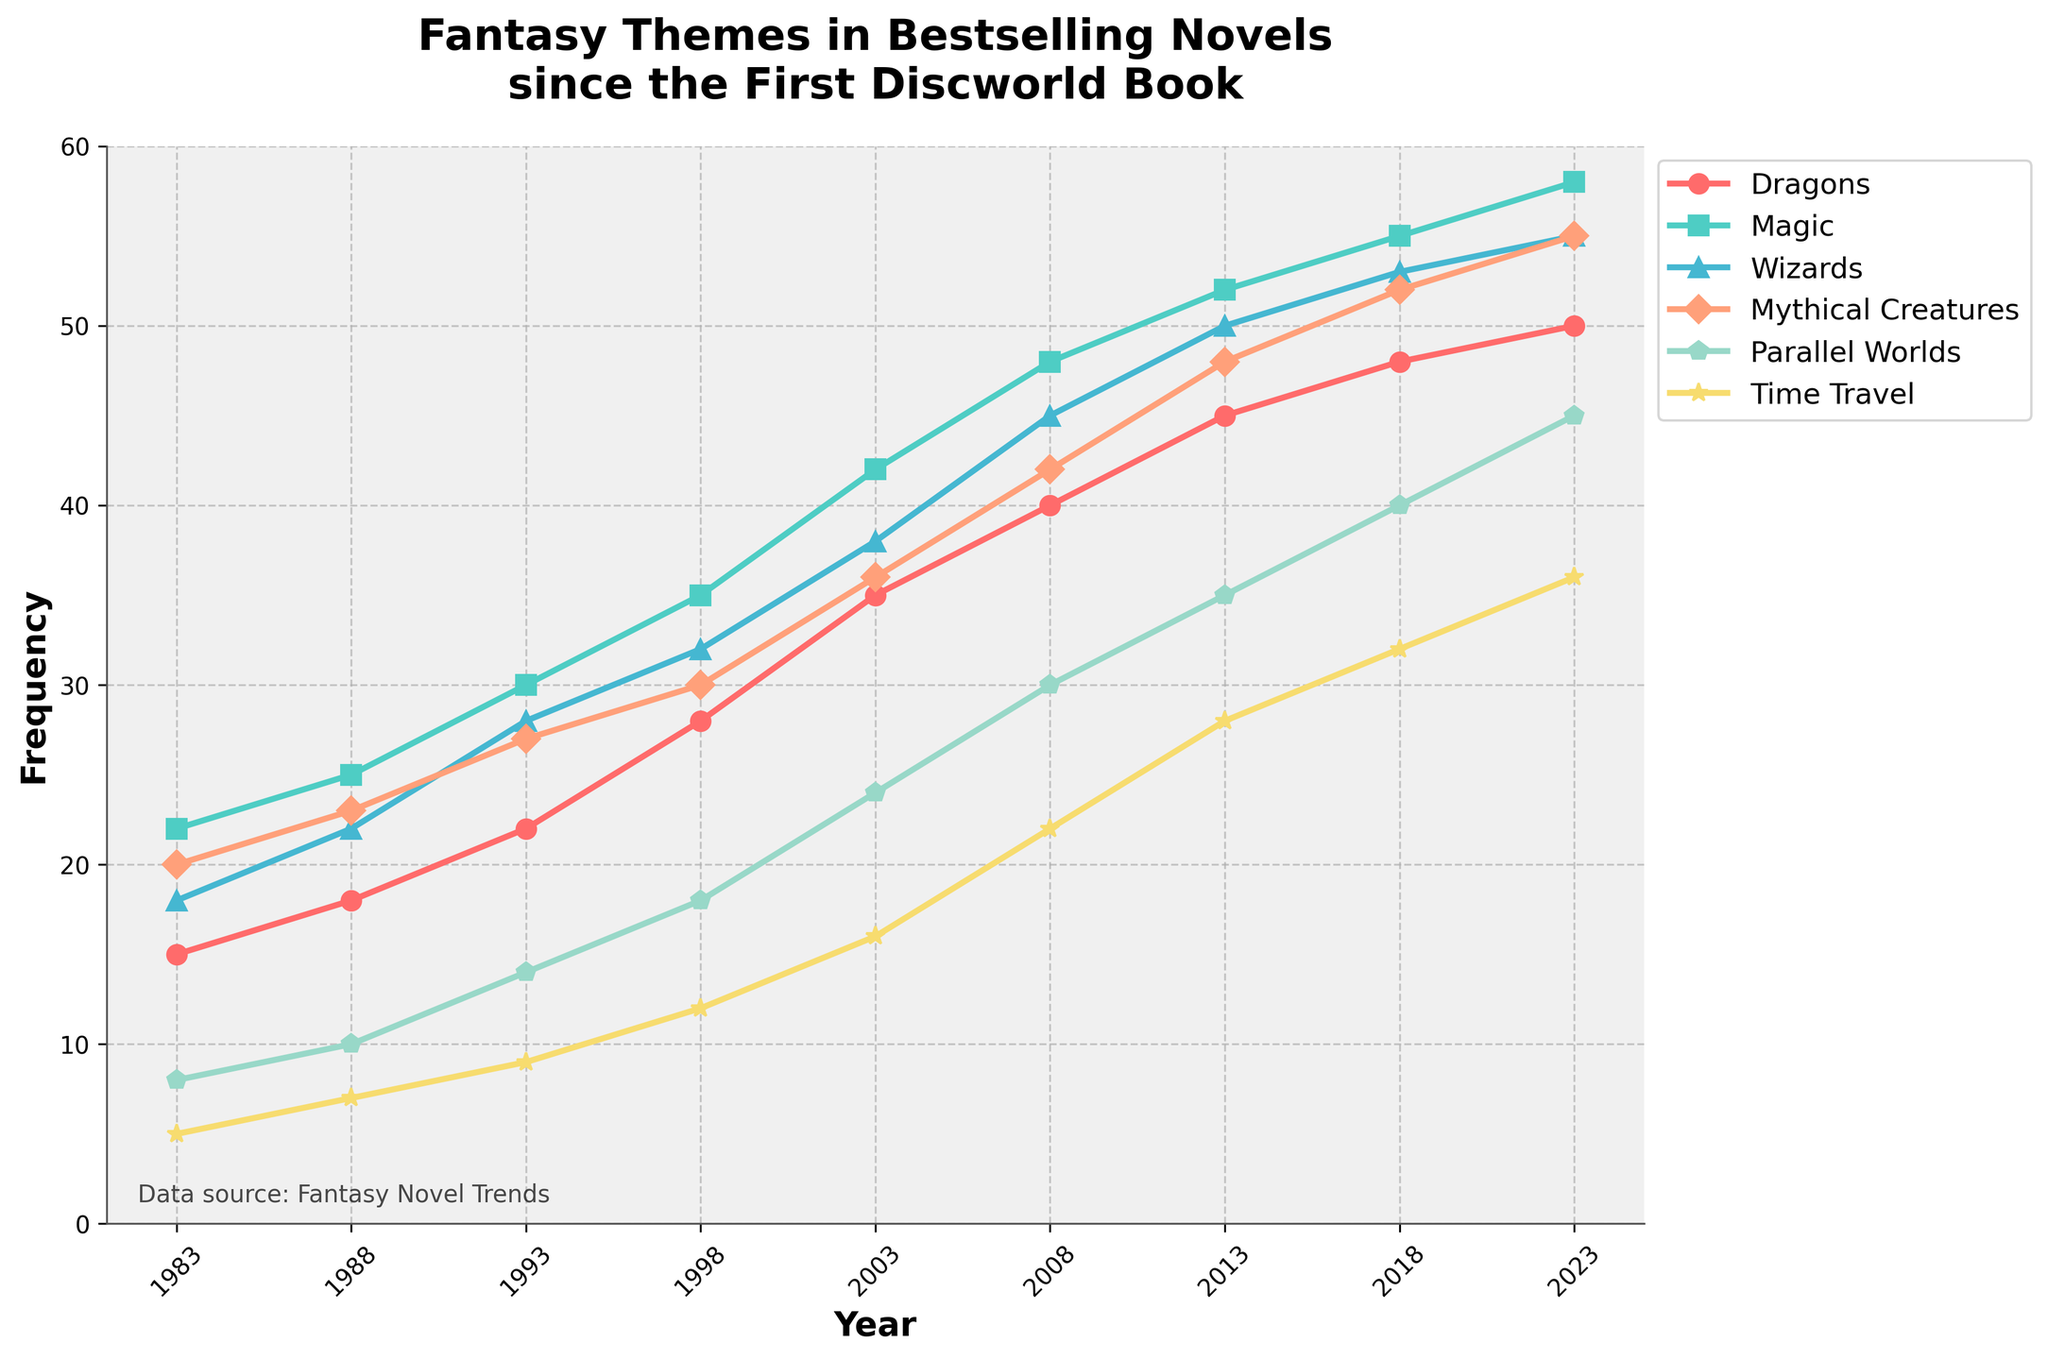What's the overall trend for the frequency of "Wizards" from 1983 to 2023? To determine the overall trend, examine the line associated with "Wizards". The frequency increases steadily from 18 in 1983 to 55 in 2023.
Answer: Increasing Which fantasy theme shows the most increase from 1983 to 2023? To find the theme with the largest increase, calculate the difference for each theme between 1983 and 2023. "Dragons" goes from 15 to 50 (+35), "Magic" from 22 to 58 (+36), "Wizards" from 18 to 55 (+37), "Mythical Creatures" from 20 to 55 (+35), "Parallel Worlds" from 8 to 45 (+37), and "Time Travel" from 5 to 36 (+31). Both "Wizards" and "Parallel Worlds" have the highest increase at +37.
Answer: Wizards, Parallel Worlds In which year did "Magic" surpass 50 in frequency? Check the data points for "Magic" to see during which year this line crosses the 50 mark. It surpasses 50 in 2013.
Answer: 2013 How does the frequency of "Time Travel" compare to "Dragons" in 2003? In 2003, the frequency of "Time Travel" is 16, while "Dragons" is 35.
Answer: Dragons > Time Travel If you sum the frequencies of "Dragons" and "Magic" in 2018, what is the result? Add the frequencies of "Dragons" (48) and "Magic" (55) for the year 2018. 48 + 55 = 103.
Answer: 103 Which theme had the least frequency in 1983? Compare the frequencies for all themes in 1983: Dragons (15), Magic (22), Wizards (18), Mythical Creatures (20), Parallel Worlds (8), Time Travel (5). The lowest is "Time Travel" with 5.
Answer: Time Travel Did "Mythical Creatures" ever have a lower frequency than "Dragons"? Compare the lines for "Mythical Creatures" and "Dragons" across the years. "Mythical Creatures" always have higher or equal values compared to "Dragons".
Answer: No In which years is the frequency of "Parallel Worlds" closest to the frequency of "Magic"? Look for years when the lines for "Parallel Worlds" and "Magic" are close. The closest values appear around 2023 with "Parallel Worlds" at 45 and "Magic" at 58.
Answer: 2023 What is the frequency difference between "Wizards" and "Mythical Creatures" in 1998? Calculate the difference: "Wizards" (32) - "Mythical Creatures" (30) = 2.
Answer: 2 Across all years, which theme shows the steadiest increase without any drop? All themes need to be checked for any decrease. "Magic" and "Wizards" both show steady increases without any drops each year.
Answer: Magic, Wizards 